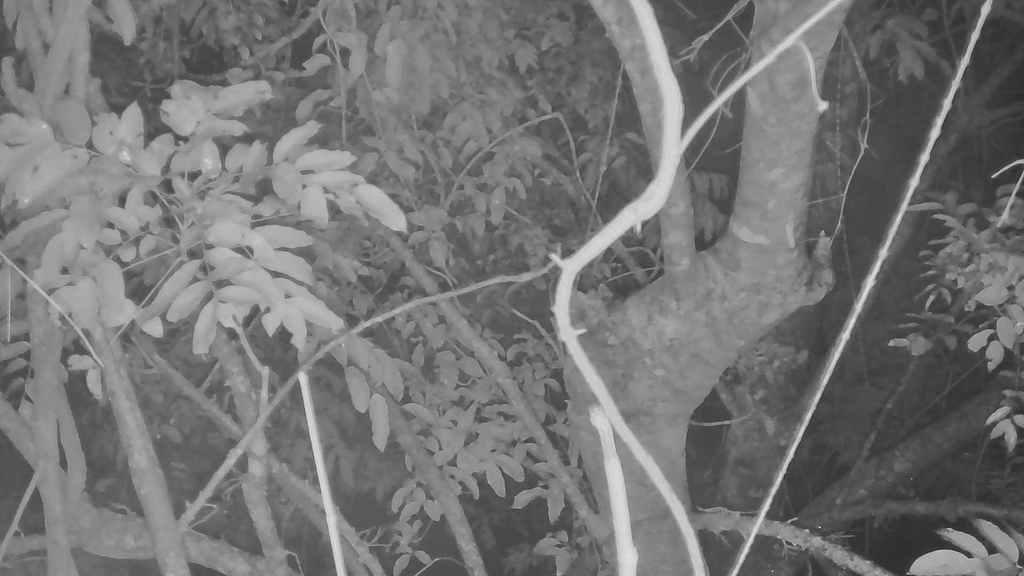What is the color scheme of the image? The image is black and white. Where was the image taken? The image was taken outdoors. What type of vegetation can be seen in the image? There are trees and plants in the image. How many pizzas are visible on the linen in the image? There are no pizzas or linen present in the image; it features a black and white outdoor scene with trees and plants. 